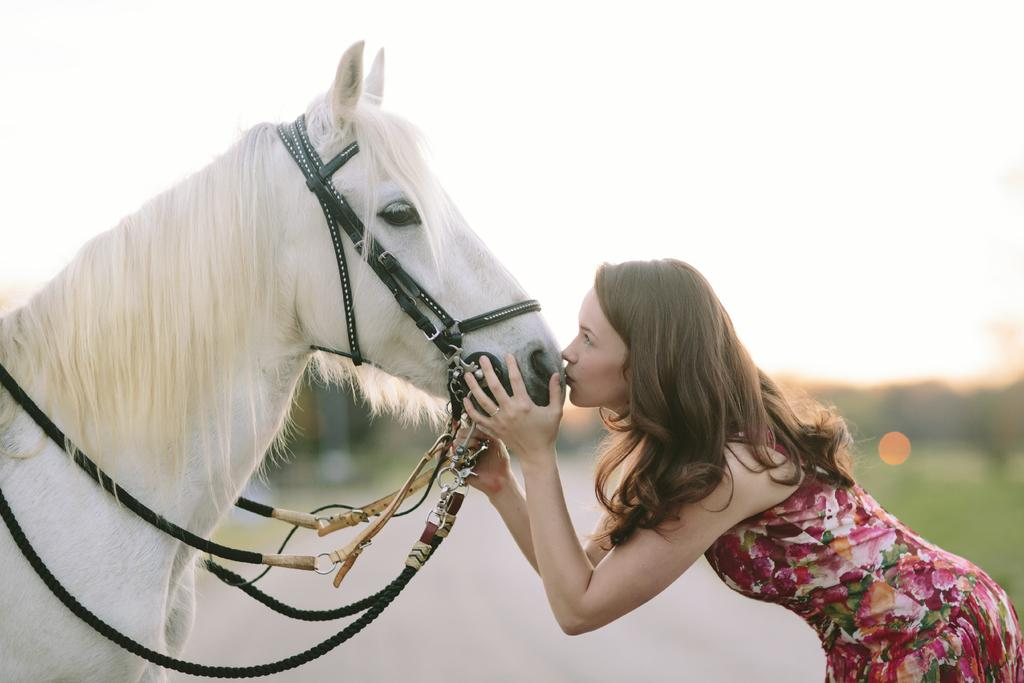What is visible at the top of the image? The sky is visible at the top of the image. Who is present in the image? There is a woman in the image. What is the woman doing in the image? The woman is kissing a white-colored horse. What is the woman's relation to the faucet in the image? There is no faucet present in the image, so it is not possible to determine the woman's relation to a faucet. 